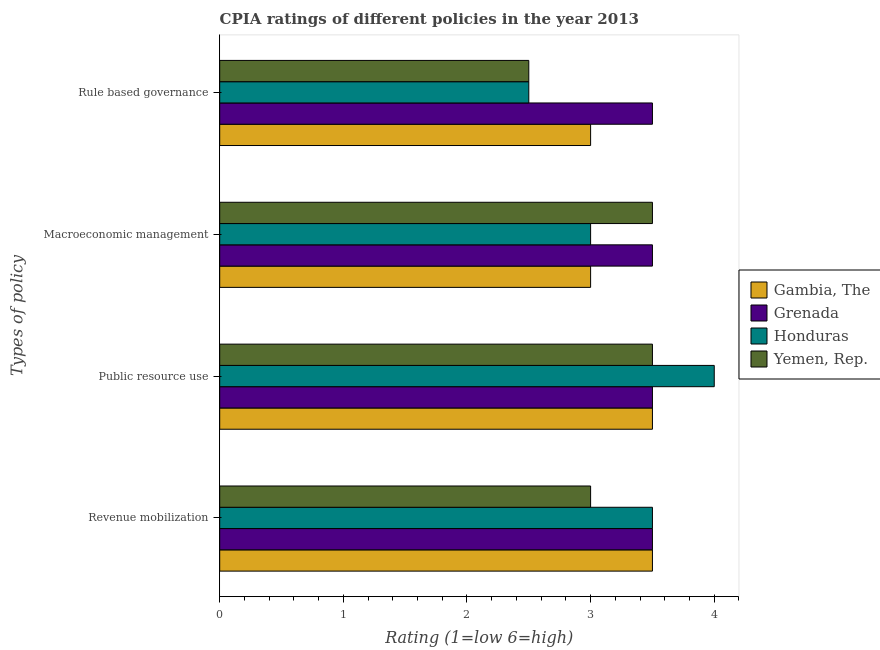How many different coloured bars are there?
Provide a succinct answer. 4. How many groups of bars are there?
Offer a very short reply. 4. Are the number of bars per tick equal to the number of legend labels?
Your answer should be very brief. Yes. How many bars are there on the 3rd tick from the top?
Make the answer very short. 4. What is the label of the 3rd group of bars from the top?
Your answer should be compact. Public resource use. Across all countries, what is the minimum cpia rating of revenue mobilization?
Your answer should be very brief. 3. In which country was the cpia rating of public resource use maximum?
Your answer should be compact. Honduras. In which country was the cpia rating of public resource use minimum?
Provide a short and direct response. Gambia, The. What is the total cpia rating of public resource use in the graph?
Make the answer very short. 14.5. What is the difference between the cpia rating of revenue mobilization in Yemen, Rep. and that in Gambia, The?
Offer a very short reply. -0.5. What is the average cpia rating of rule based governance per country?
Offer a very short reply. 2.88. What is the difference between the cpia rating of rule based governance and cpia rating of macroeconomic management in Grenada?
Your response must be concise. 0. In how many countries, is the cpia rating of macroeconomic management greater than 2.8 ?
Offer a terse response. 4. What is the ratio of the cpia rating of revenue mobilization in Gambia, The to that in Grenada?
Give a very brief answer. 1. Is the cpia rating of public resource use in Yemen, Rep. less than that in Gambia, The?
Keep it short and to the point. No. Is the difference between the cpia rating of public resource use in Grenada and Yemen, Rep. greater than the difference between the cpia rating of macroeconomic management in Grenada and Yemen, Rep.?
Provide a short and direct response. No. What is the difference between the highest and the second highest cpia rating of public resource use?
Offer a very short reply. 0.5. What is the difference between the highest and the lowest cpia rating of revenue mobilization?
Ensure brevity in your answer.  0.5. Is the sum of the cpia rating of macroeconomic management in Gambia, The and Yemen, Rep. greater than the maximum cpia rating of rule based governance across all countries?
Make the answer very short. Yes. Is it the case that in every country, the sum of the cpia rating of macroeconomic management and cpia rating of public resource use is greater than the sum of cpia rating of rule based governance and cpia rating of revenue mobilization?
Ensure brevity in your answer.  No. What does the 3rd bar from the top in Rule based governance represents?
Give a very brief answer. Grenada. What does the 1st bar from the bottom in Public resource use represents?
Provide a short and direct response. Gambia, The. How many countries are there in the graph?
Provide a succinct answer. 4. What is the difference between two consecutive major ticks on the X-axis?
Provide a succinct answer. 1. Are the values on the major ticks of X-axis written in scientific E-notation?
Provide a succinct answer. No. Where does the legend appear in the graph?
Provide a succinct answer. Center right. How are the legend labels stacked?
Provide a succinct answer. Vertical. What is the title of the graph?
Keep it short and to the point. CPIA ratings of different policies in the year 2013. What is the label or title of the Y-axis?
Make the answer very short. Types of policy. What is the Rating (1=low 6=high) of Yemen, Rep. in Revenue mobilization?
Your response must be concise. 3. What is the Rating (1=low 6=high) of Honduras in Public resource use?
Offer a terse response. 4. What is the Rating (1=low 6=high) of Grenada in Macroeconomic management?
Provide a succinct answer. 3.5. What is the Rating (1=low 6=high) in Yemen, Rep. in Macroeconomic management?
Give a very brief answer. 3.5. Across all Types of policy, what is the maximum Rating (1=low 6=high) of Gambia, The?
Keep it short and to the point. 3.5. Across all Types of policy, what is the maximum Rating (1=low 6=high) in Yemen, Rep.?
Your answer should be very brief. 3.5. Across all Types of policy, what is the minimum Rating (1=low 6=high) of Yemen, Rep.?
Keep it short and to the point. 2.5. What is the total Rating (1=low 6=high) in Honduras in the graph?
Make the answer very short. 13. What is the total Rating (1=low 6=high) in Yemen, Rep. in the graph?
Ensure brevity in your answer.  12.5. What is the difference between the Rating (1=low 6=high) of Grenada in Revenue mobilization and that in Public resource use?
Ensure brevity in your answer.  0. What is the difference between the Rating (1=low 6=high) of Yemen, Rep. in Revenue mobilization and that in Public resource use?
Ensure brevity in your answer.  -0.5. What is the difference between the Rating (1=low 6=high) in Gambia, The in Revenue mobilization and that in Macroeconomic management?
Offer a terse response. 0.5. What is the difference between the Rating (1=low 6=high) in Yemen, Rep. in Revenue mobilization and that in Macroeconomic management?
Give a very brief answer. -0.5. What is the difference between the Rating (1=low 6=high) of Gambia, The in Revenue mobilization and that in Rule based governance?
Your response must be concise. 0.5. What is the difference between the Rating (1=low 6=high) of Grenada in Revenue mobilization and that in Rule based governance?
Ensure brevity in your answer.  0. What is the difference between the Rating (1=low 6=high) of Yemen, Rep. in Revenue mobilization and that in Rule based governance?
Offer a very short reply. 0.5. What is the difference between the Rating (1=low 6=high) of Grenada in Public resource use and that in Macroeconomic management?
Offer a terse response. 0. What is the difference between the Rating (1=low 6=high) in Yemen, Rep. in Public resource use and that in Macroeconomic management?
Keep it short and to the point. 0. What is the difference between the Rating (1=low 6=high) in Grenada in Public resource use and that in Rule based governance?
Your answer should be very brief. 0. What is the difference between the Rating (1=low 6=high) in Honduras in Public resource use and that in Rule based governance?
Make the answer very short. 1.5. What is the difference between the Rating (1=low 6=high) in Grenada in Macroeconomic management and that in Rule based governance?
Provide a short and direct response. 0. What is the difference between the Rating (1=low 6=high) of Honduras in Macroeconomic management and that in Rule based governance?
Make the answer very short. 0.5. What is the difference between the Rating (1=low 6=high) in Gambia, The in Revenue mobilization and the Rating (1=low 6=high) in Honduras in Public resource use?
Your response must be concise. -0.5. What is the difference between the Rating (1=low 6=high) in Gambia, The in Revenue mobilization and the Rating (1=low 6=high) in Yemen, Rep. in Public resource use?
Your response must be concise. 0. What is the difference between the Rating (1=low 6=high) of Grenada in Revenue mobilization and the Rating (1=low 6=high) of Yemen, Rep. in Public resource use?
Provide a succinct answer. 0. What is the difference between the Rating (1=low 6=high) of Gambia, The in Revenue mobilization and the Rating (1=low 6=high) of Grenada in Macroeconomic management?
Make the answer very short. 0. What is the difference between the Rating (1=low 6=high) in Gambia, The in Revenue mobilization and the Rating (1=low 6=high) in Yemen, Rep. in Macroeconomic management?
Your response must be concise. 0. What is the difference between the Rating (1=low 6=high) in Grenada in Revenue mobilization and the Rating (1=low 6=high) in Honduras in Macroeconomic management?
Your response must be concise. 0.5. What is the difference between the Rating (1=low 6=high) of Grenada in Revenue mobilization and the Rating (1=low 6=high) of Yemen, Rep. in Macroeconomic management?
Your response must be concise. 0. What is the difference between the Rating (1=low 6=high) in Gambia, The in Revenue mobilization and the Rating (1=low 6=high) in Grenada in Rule based governance?
Keep it short and to the point. 0. What is the difference between the Rating (1=low 6=high) of Gambia, The in Revenue mobilization and the Rating (1=low 6=high) of Honduras in Rule based governance?
Provide a succinct answer. 1. What is the difference between the Rating (1=low 6=high) in Gambia, The in Revenue mobilization and the Rating (1=low 6=high) in Yemen, Rep. in Rule based governance?
Make the answer very short. 1. What is the difference between the Rating (1=low 6=high) in Grenada in Revenue mobilization and the Rating (1=low 6=high) in Yemen, Rep. in Rule based governance?
Keep it short and to the point. 1. What is the difference between the Rating (1=low 6=high) in Honduras in Revenue mobilization and the Rating (1=low 6=high) in Yemen, Rep. in Rule based governance?
Your answer should be very brief. 1. What is the difference between the Rating (1=low 6=high) in Gambia, The in Public resource use and the Rating (1=low 6=high) in Grenada in Macroeconomic management?
Make the answer very short. 0. What is the difference between the Rating (1=low 6=high) in Gambia, The in Public resource use and the Rating (1=low 6=high) in Honduras in Macroeconomic management?
Give a very brief answer. 0.5. What is the difference between the Rating (1=low 6=high) in Grenada in Public resource use and the Rating (1=low 6=high) in Honduras in Macroeconomic management?
Your response must be concise. 0.5. What is the difference between the Rating (1=low 6=high) of Honduras in Public resource use and the Rating (1=low 6=high) of Yemen, Rep. in Macroeconomic management?
Make the answer very short. 0.5. What is the difference between the Rating (1=low 6=high) of Gambia, The in Public resource use and the Rating (1=low 6=high) of Grenada in Rule based governance?
Provide a short and direct response. 0. What is the difference between the Rating (1=low 6=high) in Gambia, The in Public resource use and the Rating (1=low 6=high) in Honduras in Rule based governance?
Offer a very short reply. 1. What is the difference between the Rating (1=low 6=high) in Grenada in Public resource use and the Rating (1=low 6=high) in Honduras in Rule based governance?
Keep it short and to the point. 1. What is the difference between the Rating (1=low 6=high) of Grenada in Public resource use and the Rating (1=low 6=high) of Yemen, Rep. in Rule based governance?
Provide a succinct answer. 1. What is the difference between the Rating (1=low 6=high) in Honduras in Public resource use and the Rating (1=low 6=high) in Yemen, Rep. in Rule based governance?
Give a very brief answer. 1.5. What is the difference between the Rating (1=low 6=high) in Gambia, The in Macroeconomic management and the Rating (1=low 6=high) in Grenada in Rule based governance?
Ensure brevity in your answer.  -0.5. What is the difference between the Rating (1=low 6=high) in Gambia, The in Macroeconomic management and the Rating (1=low 6=high) in Yemen, Rep. in Rule based governance?
Offer a very short reply. 0.5. What is the difference between the Rating (1=low 6=high) of Grenada in Macroeconomic management and the Rating (1=low 6=high) of Honduras in Rule based governance?
Your answer should be very brief. 1. What is the difference between the Rating (1=low 6=high) in Grenada in Macroeconomic management and the Rating (1=low 6=high) in Yemen, Rep. in Rule based governance?
Offer a terse response. 1. What is the difference between the Rating (1=low 6=high) in Honduras in Macroeconomic management and the Rating (1=low 6=high) in Yemen, Rep. in Rule based governance?
Provide a short and direct response. 0.5. What is the average Rating (1=low 6=high) in Gambia, The per Types of policy?
Provide a succinct answer. 3.25. What is the average Rating (1=low 6=high) of Honduras per Types of policy?
Offer a terse response. 3.25. What is the average Rating (1=low 6=high) of Yemen, Rep. per Types of policy?
Offer a terse response. 3.12. What is the difference between the Rating (1=low 6=high) of Gambia, The and Rating (1=low 6=high) of Honduras in Revenue mobilization?
Offer a terse response. 0. What is the difference between the Rating (1=low 6=high) in Grenada and Rating (1=low 6=high) in Honduras in Revenue mobilization?
Your answer should be compact. 0. What is the difference between the Rating (1=low 6=high) of Honduras and Rating (1=low 6=high) of Yemen, Rep. in Revenue mobilization?
Your answer should be compact. 0.5. What is the difference between the Rating (1=low 6=high) in Gambia, The and Rating (1=low 6=high) in Grenada in Public resource use?
Ensure brevity in your answer.  0. What is the difference between the Rating (1=low 6=high) in Gambia, The and Rating (1=low 6=high) in Honduras in Public resource use?
Your answer should be compact. -0.5. What is the difference between the Rating (1=low 6=high) of Honduras and Rating (1=low 6=high) of Yemen, Rep. in Public resource use?
Your response must be concise. 0.5. What is the difference between the Rating (1=low 6=high) of Gambia, The and Rating (1=low 6=high) of Grenada in Macroeconomic management?
Your answer should be compact. -0.5. What is the difference between the Rating (1=low 6=high) of Grenada and Rating (1=low 6=high) of Honduras in Rule based governance?
Your answer should be compact. 1. What is the difference between the Rating (1=low 6=high) of Grenada and Rating (1=low 6=high) of Yemen, Rep. in Rule based governance?
Keep it short and to the point. 1. What is the ratio of the Rating (1=low 6=high) in Gambia, The in Revenue mobilization to that in Public resource use?
Provide a succinct answer. 1. What is the ratio of the Rating (1=low 6=high) in Grenada in Revenue mobilization to that in Public resource use?
Ensure brevity in your answer.  1. What is the ratio of the Rating (1=low 6=high) of Gambia, The in Revenue mobilization to that in Macroeconomic management?
Keep it short and to the point. 1.17. What is the ratio of the Rating (1=low 6=high) in Grenada in Revenue mobilization to that in Macroeconomic management?
Give a very brief answer. 1. What is the ratio of the Rating (1=low 6=high) in Honduras in Revenue mobilization to that in Rule based governance?
Provide a succinct answer. 1.4. What is the ratio of the Rating (1=low 6=high) in Gambia, The in Public resource use to that in Macroeconomic management?
Provide a short and direct response. 1.17. What is the ratio of the Rating (1=low 6=high) in Honduras in Public resource use to that in Macroeconomic management?
Give a very brief answer. 1.33. What is the ratio of the Rating (1=low 6=high) in Grenada in Public resource use to that in Rule based governance?
Offer a very short reply. 1. What is the ratio of the Rating (1=low 6=high) of Honduras in Public resource use to that in Rule based governance?
Ensure brevity in your answer.  1.6. What is the ratio of the Rating (1=low 6=high) in Grenada in Macroeconomic management to that in Rule based governance?
Provide a succinct answer. 1. What is the ratio of the Rating (1=low 6=high) of Honduras in Macroeconomic management to that in Rule based governance?
Offer a very short reply. 1.2. What is the ratio of the Rating (1=low 6=high) of Yemen, Rep. in Macroeconomic management to that in Rule based governance?
Make the answer very short. 1.4. What is the difference between the highest and the second highest Rating (1=low 6=high) in Gambia, The?
Keep it short and to the point. 0. What is the difference between the highest and the second highest Rating (1=low 6=high) of Honduras?
Offer a very short reply. 0.5. What is the difference between the highest and the lowest Rating (1=low 6=high) in Gambia, The?
Your answer should be very brief. 0.5. What is the difference between the highest and the lowest Rating (1=low 6=high) in Grenada?
Make the answer very short. 0. What is the difference between the highest and the lowest Rating (1=low 6=high) in Honduras?
Provide a succinct answer. 1.5. What is the difference between the highest and the lowest Rating (1=low 6=high) in Yemen, Rep.?
Offer a terse response. 1. 